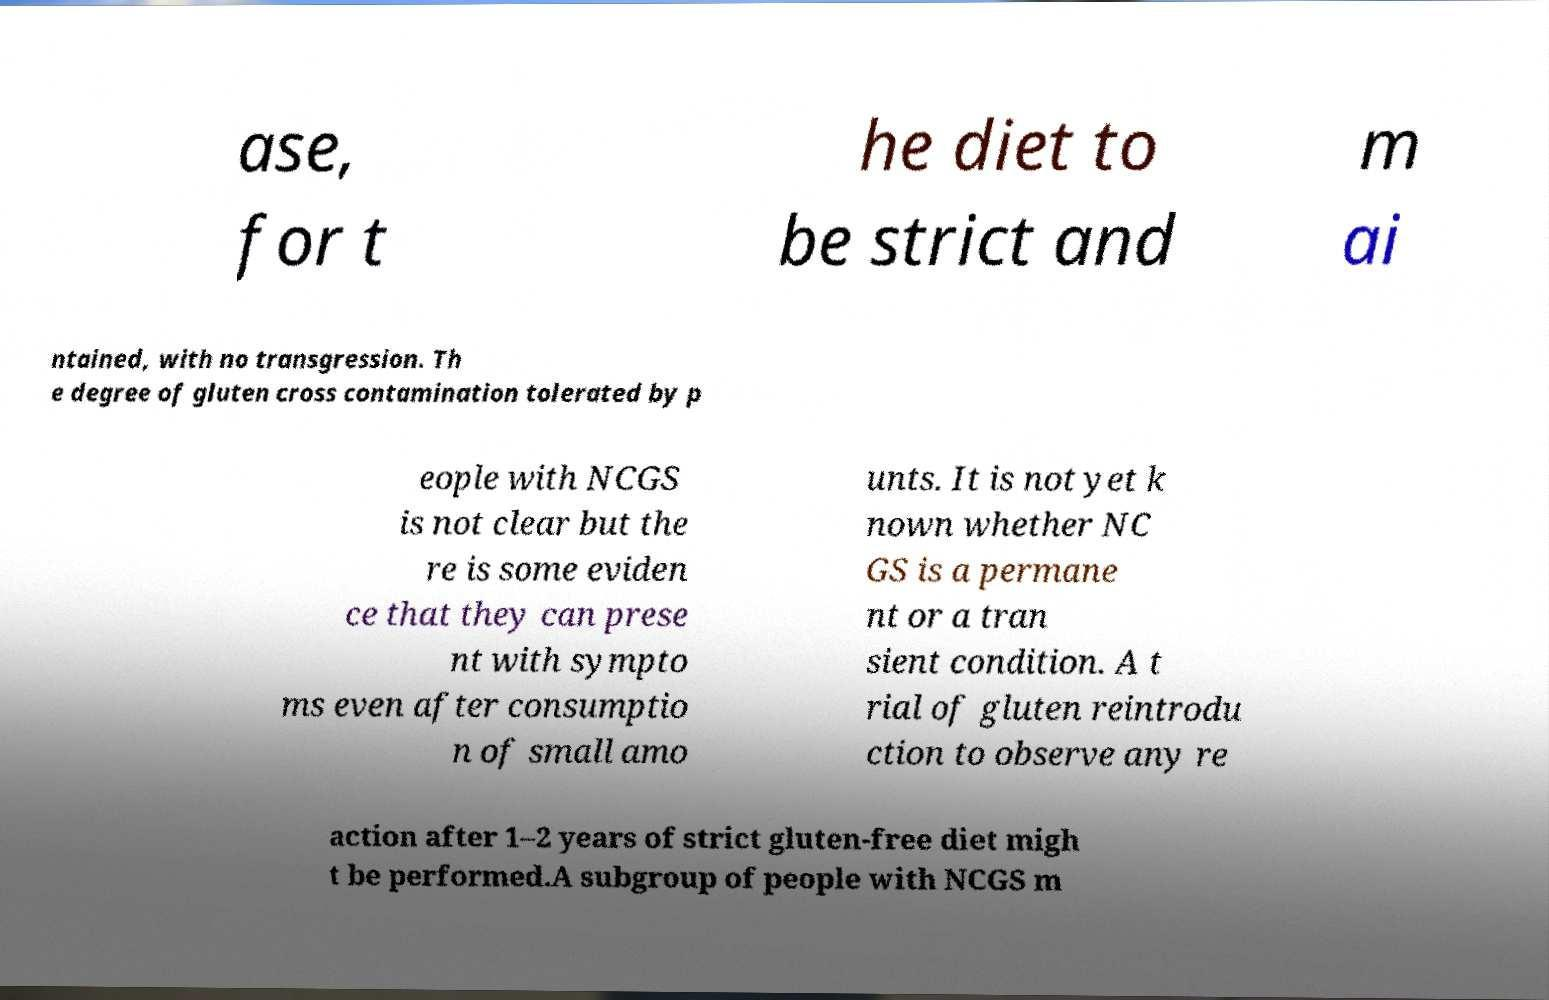Could you assist in decoding the text presented in this image and type it out clearly? ase, for t he diet to be strict and m ai ntained, with no transgression. Th e degree of gluten cross contamination tolerated by p eople with NCGS is not clear but the re is some eviden ce that they can prese nt with sympto ms even after consumptio n of small amo unts. It is not yet k nown whether NC GS is a permane nt or a tran sient condition. A t rial of gluten reintrodu ction to observe any re action after 1–2 years of strict gluten-free diet migh t be performed.A subgroup of people with NCGS m 